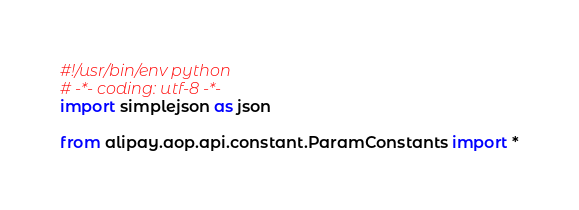<code> <loc_0><loc_0><loc_500><loc_500><_Python_>#!/usr/bin/env python
# -*- coding: utf-8 -*-
import simplejson as json

from alipay.aop.api.constant.ParamConstants import *</code> 